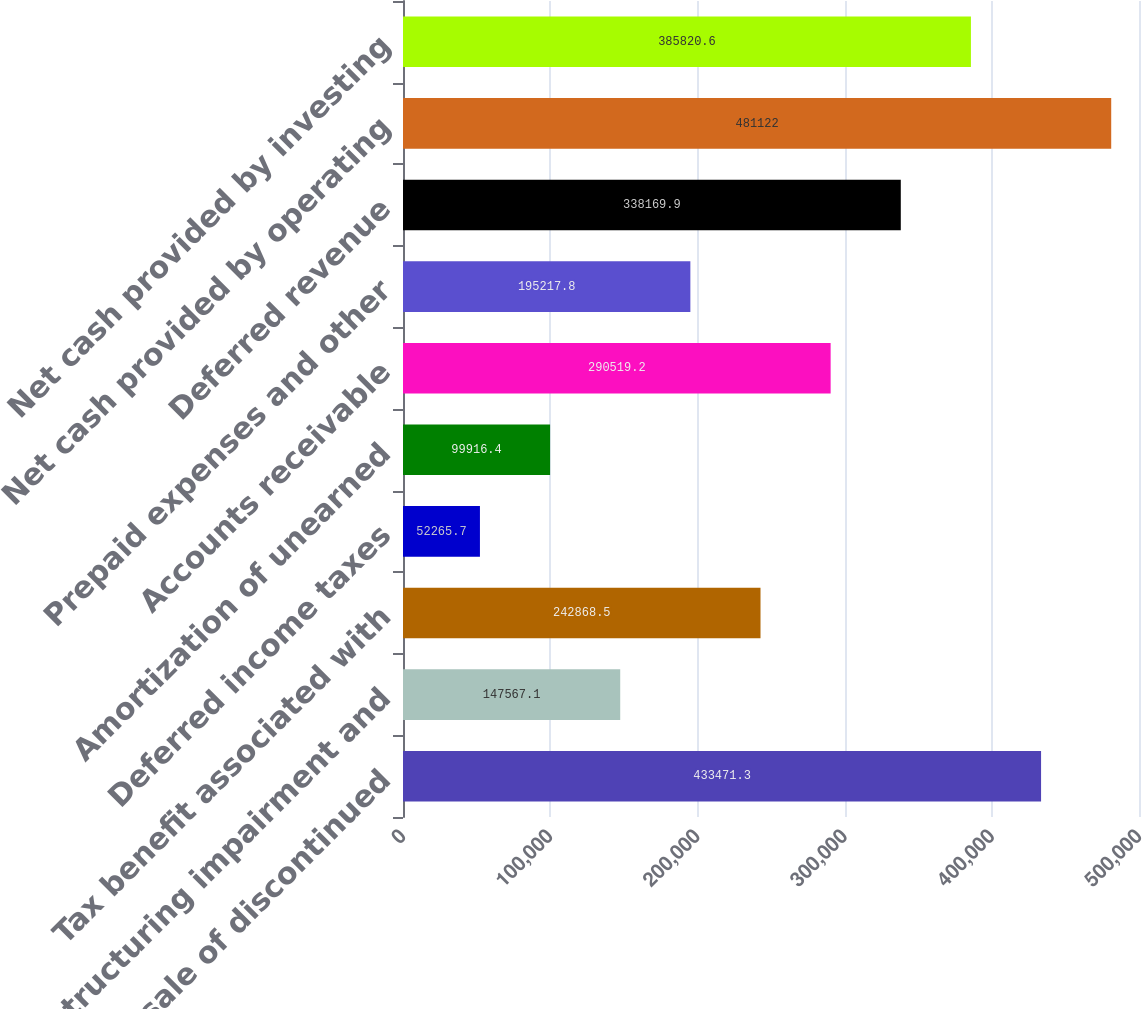<chart> <loc_0><loc_0><loc_500><loc_500><bar_chart><fcel>Gain on sale of discontinued<fcel>Restructuring impairment and<fcel>Tax benefit associated with<fcel>Deferred income taxes<fcel>Amortization of unearned<fcel>Accounts receivable<fcel>Prepaid expenses and other<fcel>Deferred revenue<fcel>Net cash provided by operating<fcel>Net cash provided by investing<nl><fcel>433471<fcel>147567<fcel>242868<fcel>52265.7<fcel>99916.4<fcel>290519<fcel>195218<fcel>338170<fcel>481122<fcel>385821<nl></chart> 